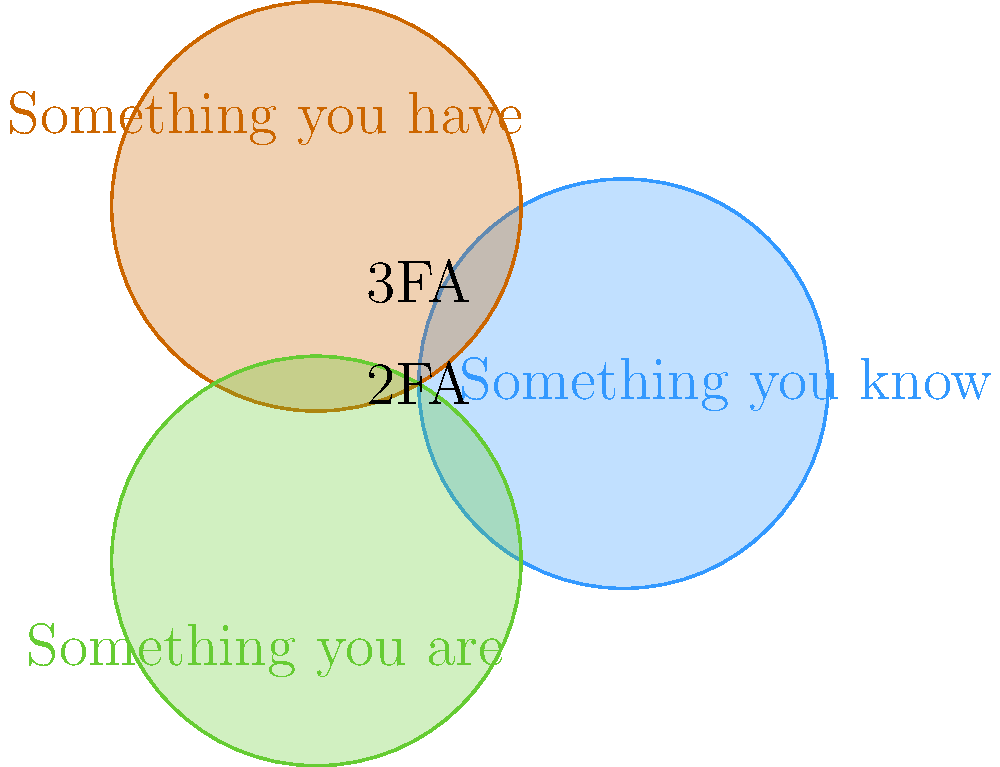Analise o diagrama de Venn que representa os fatores de autenticação em sistemas de segurança digital. Qual combinação de fatores ofereceria o nível mais alto de segurança para sistemas governamentais críticos, e por que essa combinação é considerada a mais robusta contra ameaças cibernéticas modernas? Para responder a esta questão, vamos analisar o diagrama e considerar os fatores de autenticação apresentados:

1. "Something you know" (Algo que você sabe): Geralmente se refere a senhas ou PINs.
2. "Something you have" (Algo que você possui): Pode ser um token físico, smartphone, ou cartão inteligente.
3. "Something you are" (Algo que você é): Refere-se a características biométricas como impressão digital ou reconhecimento facial.

O diagrama mostra as interseções entre estes fatores, indicando:
- 2FA (Autenticação de dois fatores): Onde dois círculos se sobrepõem.
- 3FA (Autenticação de três fatores): No centro, onde todos os três círculos se sobrepõem.

A combinação que oferece o nível mais alto de segurança é a autenticação de três fatores (3FA), que utiliza todos os três tipos de fatores simultaneamente. Esta é considerada a mais robusta porque:

1. Aumenta significativamente a dificuldade de acesso não autorizado, pois um atacante precisaria comprometer três tipos diferentes de autenticação.
2. Compensa as fraquezas individuais de cada fator:
   - Senhas podem ser adivinhadas ou roubadas.
   - Dispositivos físicos podem ser perdidos ou roubados.
   - Dados biométricos, embora únicos, podem ser potencialmente falsificados em casos extremos.

3. Proporciona camadas adicionais de segurança, tornando quase impossível para um atacante obter todos os três fatores simultaneamente.

4. É particularmente adequada para sistemas governamentais críticos, onde a segurança é primordial e os riscos de ataques cibernéticos são elevados.

5. Atende a regulamentações rigorosas de segurança digital, que frequentemente exigem múltiplos fatores de autenticação para acesso a informações sensíveis.

Portanto, a implementação de 3FA oferece o mais alto nível de segurança, crucial para proteger sistemas governamentais contra ameaças cibernéticas sofisticadas e em constante evolução.
Answer: Autenticação de três fatores (3FA) 